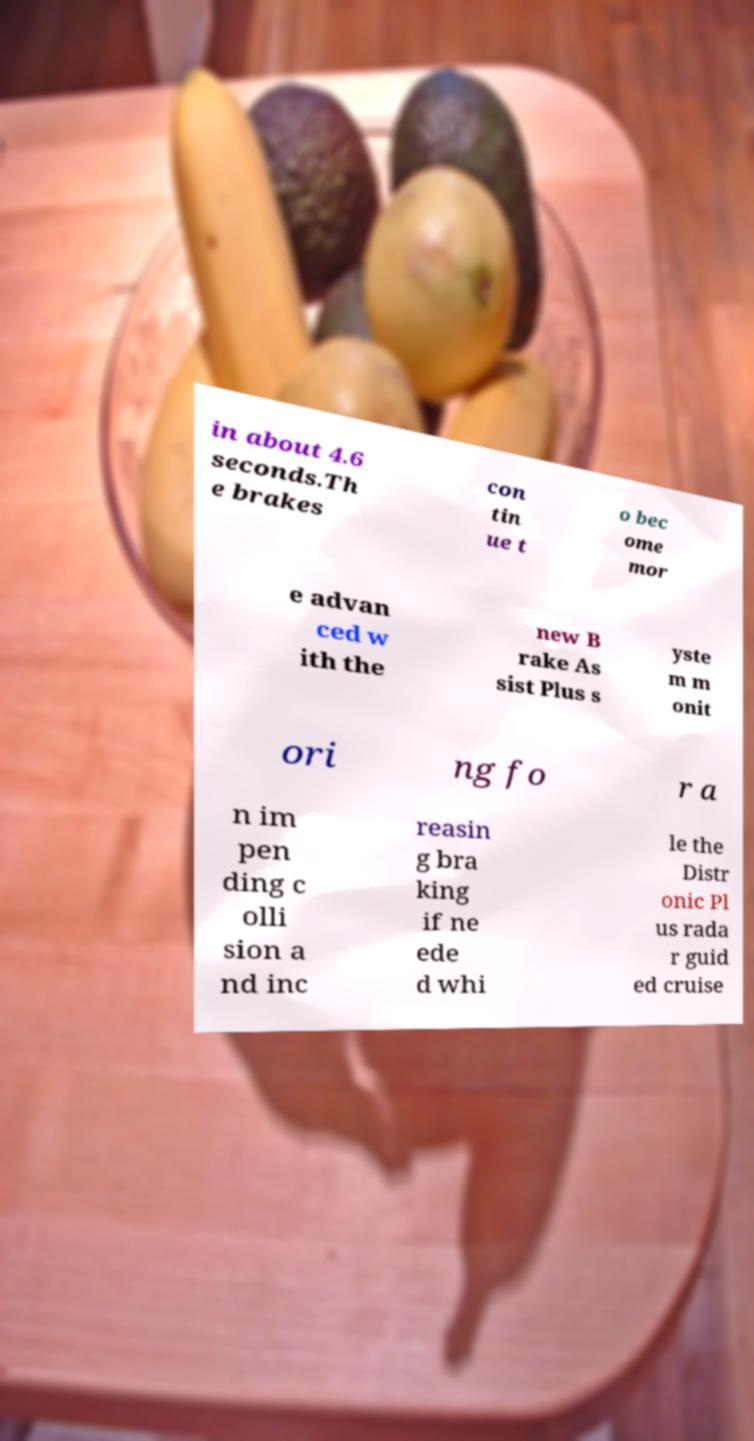Could you extract and type out the text from this image? in about 4.6 seconds.Th e brakes con tin ue t o bec ome mor e advan ced w ith the new B rake As sist Plus s yste m m onit ori ng fo r a n im pen ding c olli sion a nd inc reasin g bra king if ne ede d whi le the Distr onic Pl us rada r guid ed cruise 